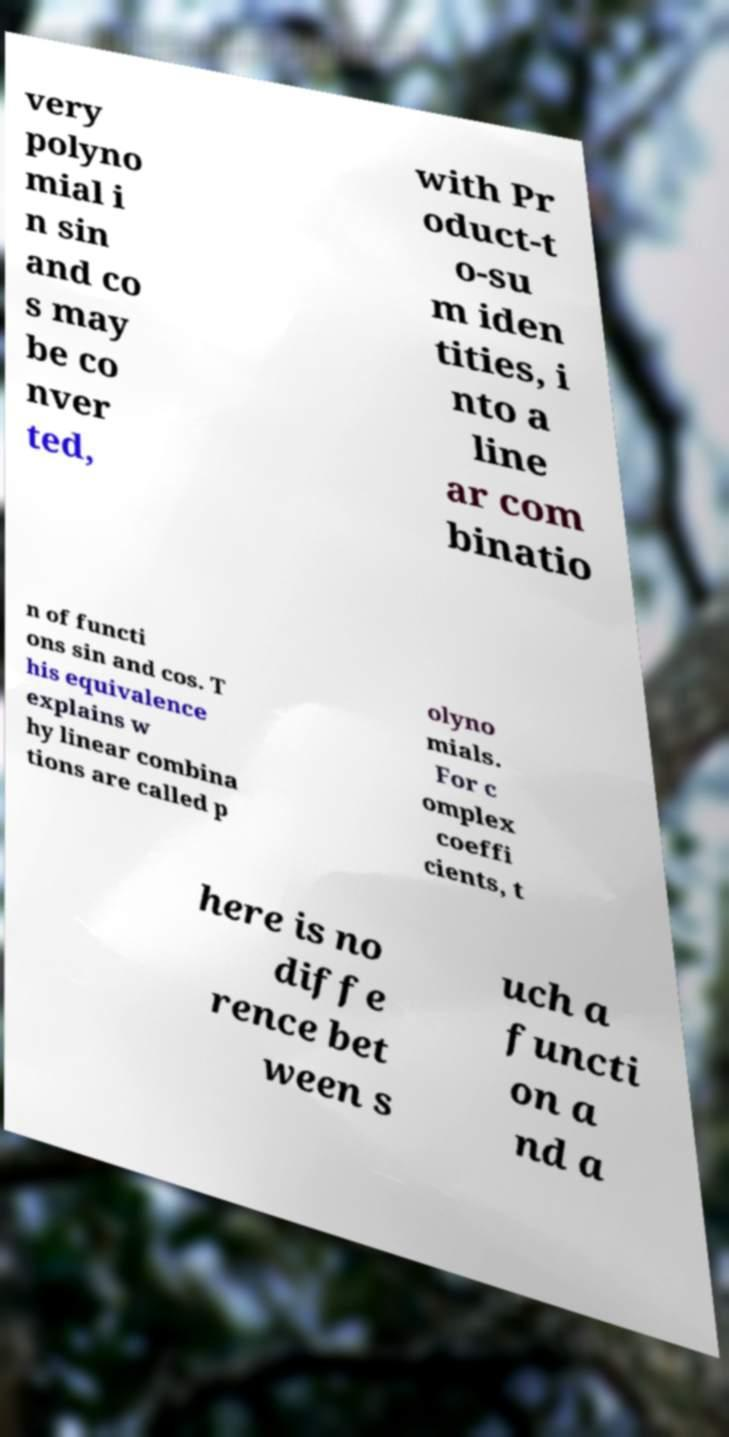For documentation purposes, I need the text within this image transcribed. Could you provide that? very polyno mial i n sin and co s may be co nver ted, with Pr oduct-t o-su m iden tities, i nto a line ar com binatio n of functi ons sin and cos. T his equivalence explains w hy linear combina tions are called p olyno mials. For c omplex coeffi cients, t here is no diffe rence bet ween s uch a functi on a nd a 